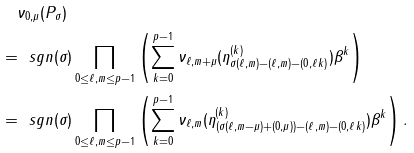Convert formula to latex. <formula><loc_0><loc_0><loc_500><loc_500>& \quad \nu _ { 0 , \mu } ( P _ { \sigma } ) \\ & = \ s g n ( \sigma ) \prod _ { 0 \leq \ell , m \leq p - 1 } \left ( \sum _ { k = 0 } ^ { p - 1 } \nu _ { \ell , m + \mu } ( \eta ^ { ( k ) } _ { \sigma ( \ell , m ) - ( \ell , m ) - ( 0 , \ell k ) } ) \beta ^ { k } \right ) \\ & = \ s g n ( \sigma ) \prod _ { 0 \leq \ell , m \leq p - 1 } \left ( \sum _ { k = 0 } ^ { p - 1 } \nu _ { \ell , m } ( \eta ^ { ( k ) } _ { ( \sigma ( \ell , m - \mu ) + ( 0 , \mu ) ) - ( \ell , m ) - ( 0 , \ell k ) } ) \beta ^ { k } \right ) .</formula> 